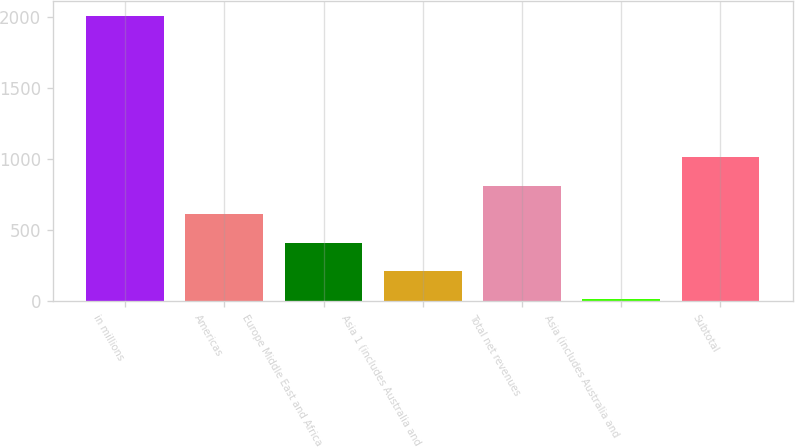Convert chart to OTSL. <chart><loc_0><loc_0><loc_500><loc_500><bar_chart><fcel>in millions<fcel>Americas<fcel>Europe Middle East and Africa<fcel>Asia 1 (includes Australia and<fcel>Total net revenues<fcel>Asia (includes Australia and<fcel>Subtotal<nl><fcel>2012<fcel>612.7<fcel>412.8<fcel>212.9<fcel>812.6<fcel>13<fcel>1012.5<nl></chart> 